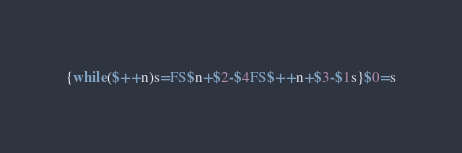Convert code to text. <code><loc_0><loc_0><loc_500><loc_500><_Awk_>{while($++n)s=FS$n+$2-$4FS$++n+$3-$1s}$0=s</code> 